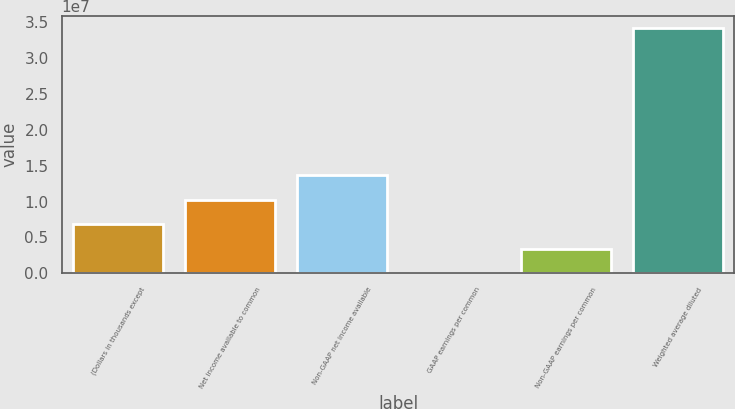Convert chart. <chart><loc_0><loc_0><loc_500><loc_500><bar_chart><fcel>(Dollars in thousands except<fcel>Net income available to common<fcel>Non-GAAP net income available<fcel>GAAP earnings per common<fcel>Non-GAAP earnings per common<fcel>Weighted average diluted<nl><fcel>6.83655e+06<fcel>1.02548e+07<fcel>1.36731e+07<fcel>0.66<fcel>3.41827e+06<fcel>3.41827e+07<nl></chart> 